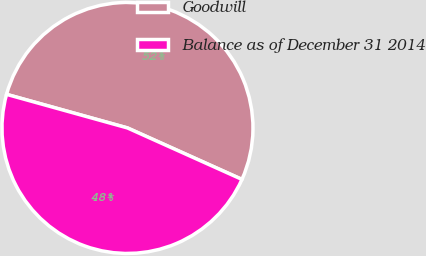Convert chart. <chart><loc_0><loc_0><loc_500><loc_500><pie_chart><fcel>Goodwill<fcel>Balance as of December 31 2014<nl><fcel>52.41%<fcel>47.59%<nl></chart> 